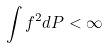Convert formula to latex. <formula><loc_0><loc_0><loc_500><loc_500>\int f ^ { 2 } d P < \infty</formula> 